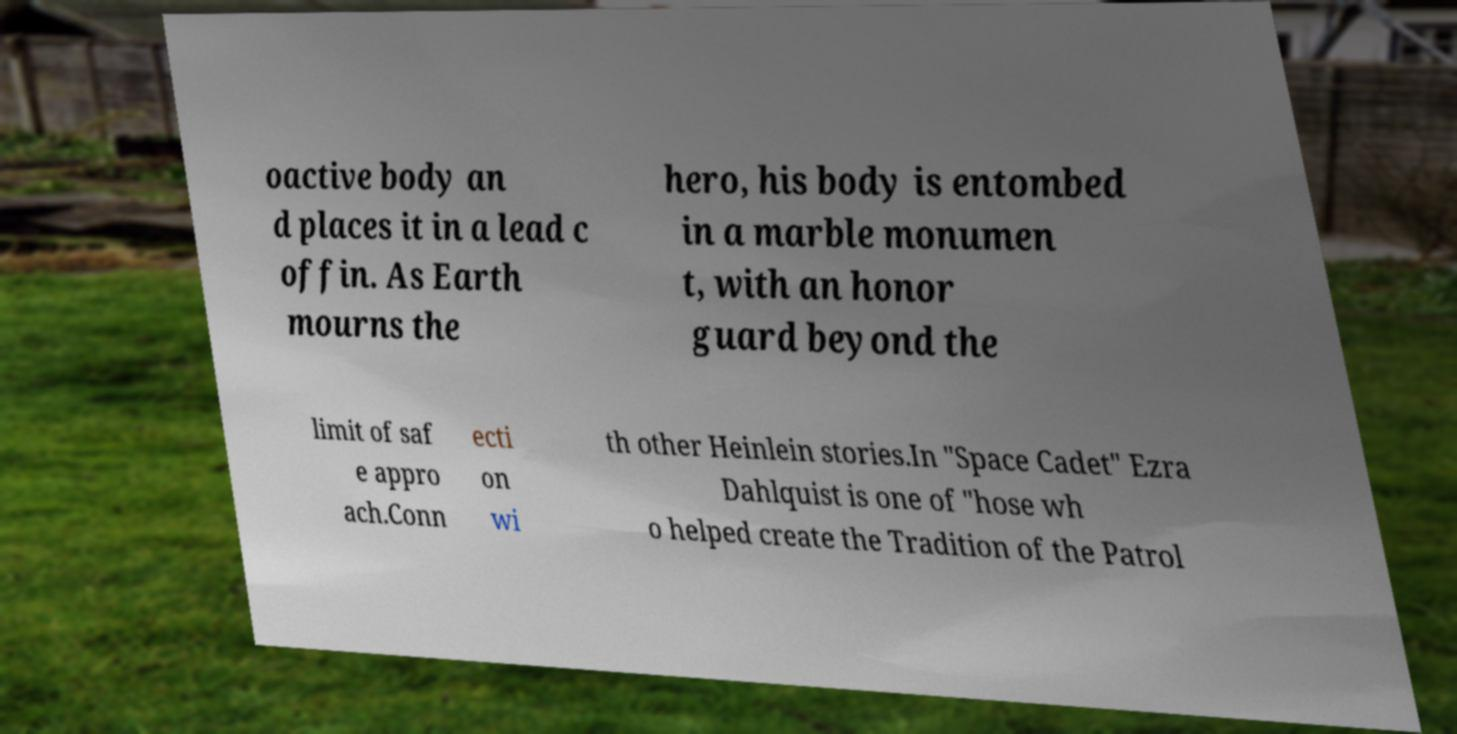Please identify and transcribe the text found in this image. oactive body an d places it in a lead c offin. As Earth mourns the hero, his body is entombed in a marble monumen t, with an honor guard beyond the limit of saf e appro ach.Conn ecti on wi th other Heinlein stories.In "Space Cadet" Ezra Dahlquist is one of "hose wh o helped create the Tradition of the Patrol 